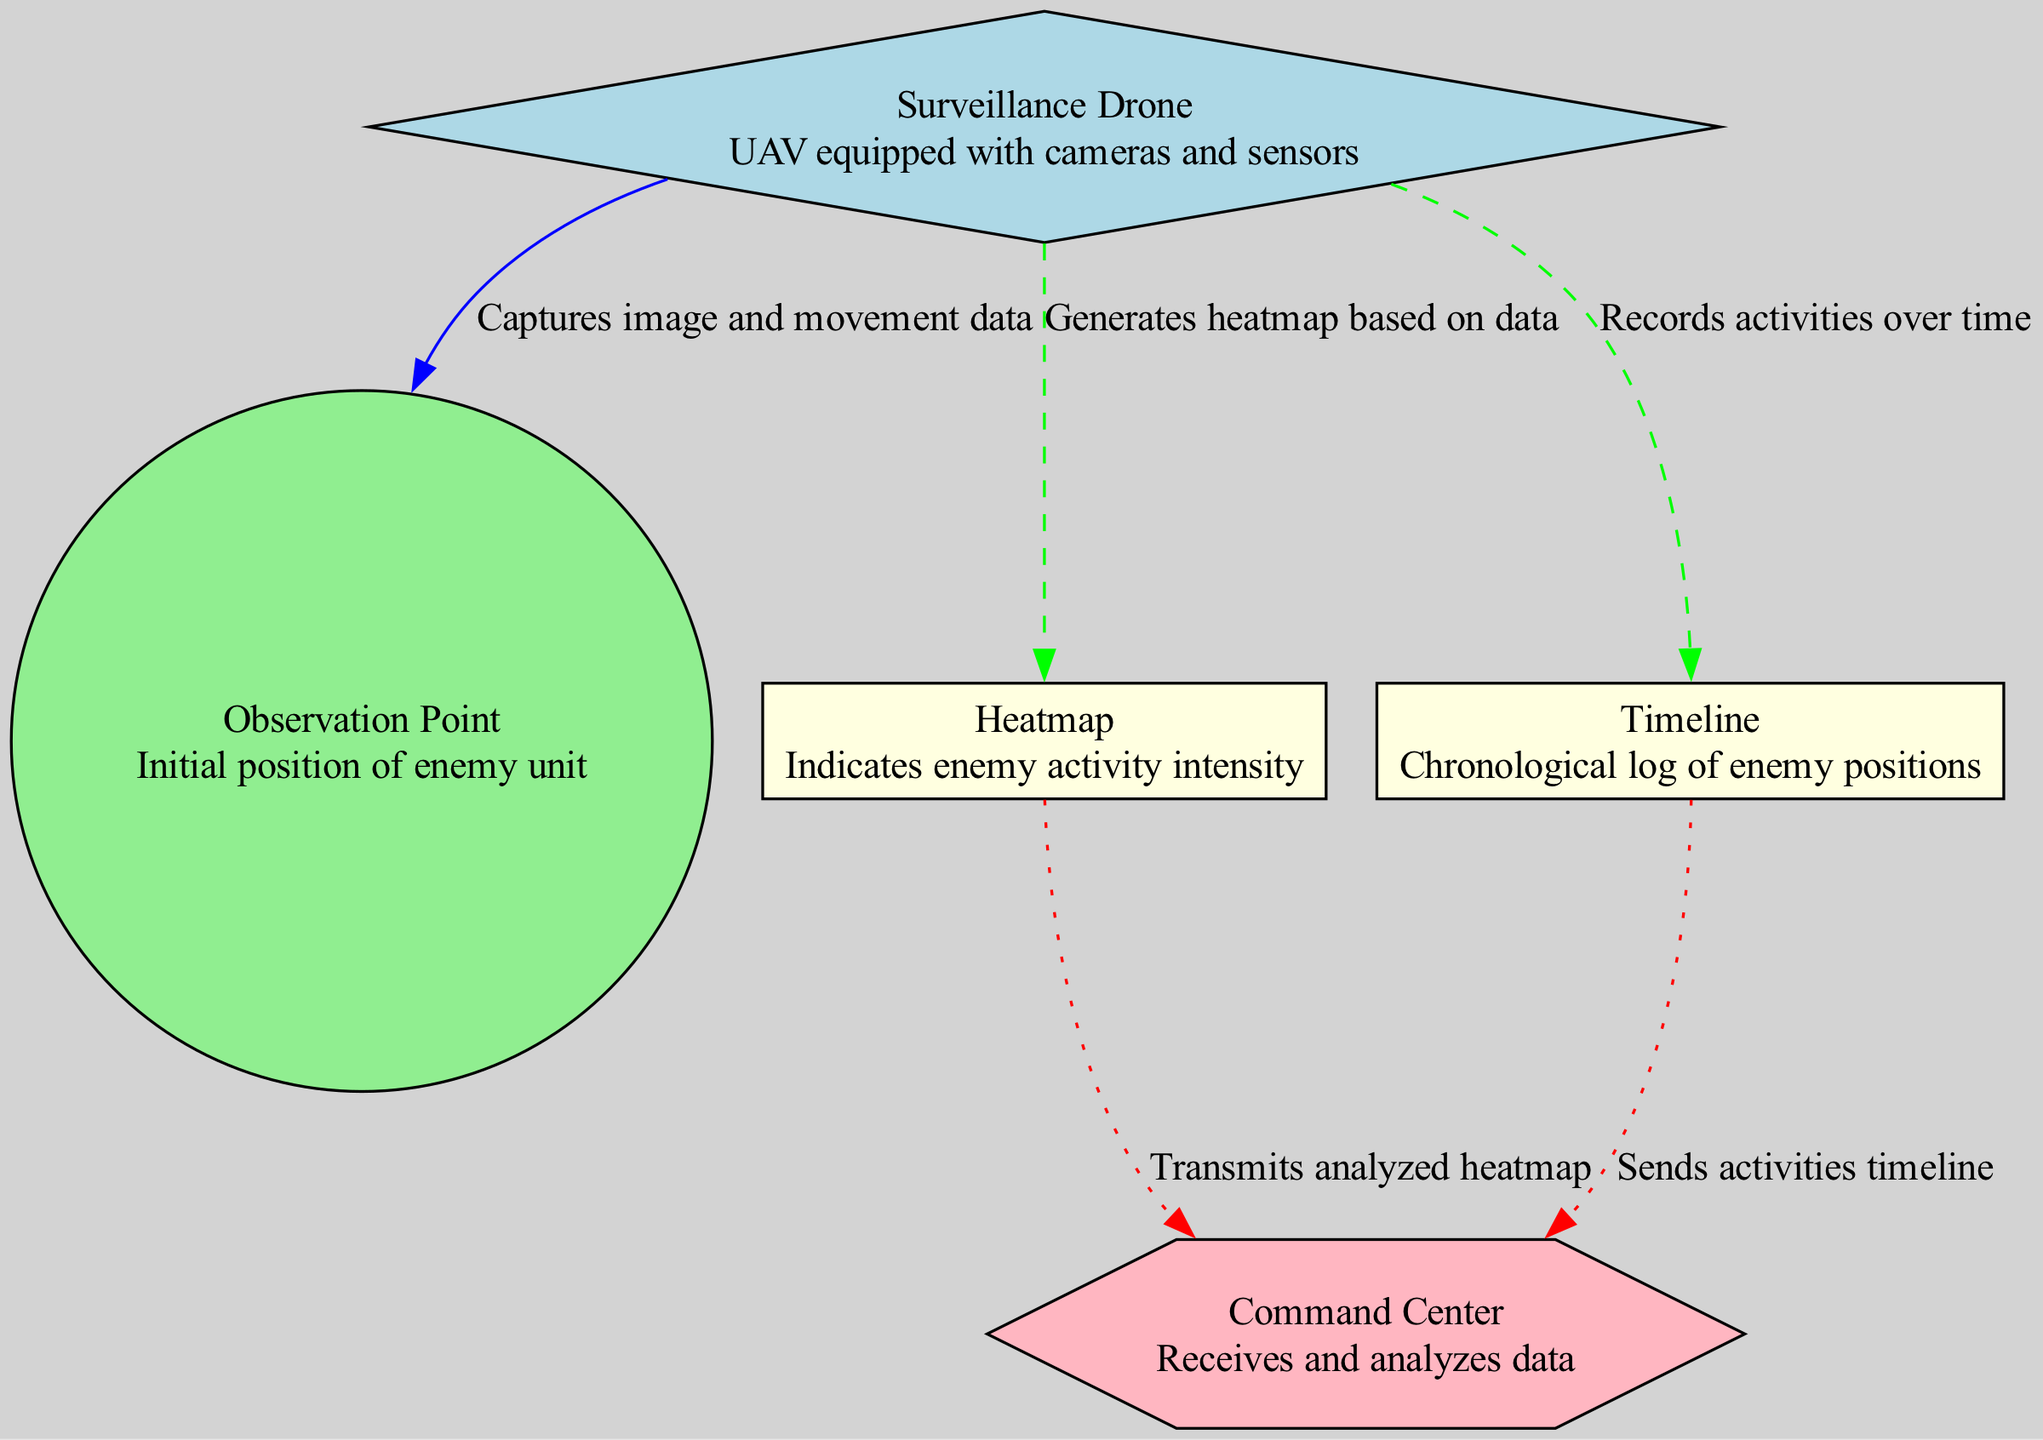What is the function of the Surveillance Drone in this diagram? The Surveillance Drone captures image and movement data from the Observation Point, which is indicated by the arrow connecting the drone to the location node.
Answer: Captures image and movement data How many nodes are present in the diagram? By counting the items listed under "nodes," there are five distinct nodes: Surveillance Drone, Observation Point, Heatmap, Timeline, and Command Center.
Answer: Five What type of visualization represents the intensity of enemy activity? The node labeled as Heatmap represents the intensity of enemy activity, as described in the node's information.
Answer: Heatmap What type of data flow occurs from the Heatmap to the Command Center? The connection from the Heatmap to the Command Center is described as data transmission, specifically indicated by the dotted line between these nodes.
Answer: Data transmission Which node is responsible for analyzing data? The Command Center node is designated as the one that receives and analyzes data, based on its description.
Answer: Command Center What is transmitted from the Timeline to the Command Center? The Timeline transmits the activities log to the Command Center, as indicated by the description of the edge connecting these nodes.
Answer: Sends activities timeline How does the diagram categorize the different types of nodes? Nodes are categorized based on their functionality: drones are diamonds, locations are circles, visualizations are rectangles, and analytical units are hexagons, illustrated by their unique shapes and colors.
Answer: By functionality Which process generates the heatmap? The heatmap is generated through data processing from the Surveillance Drone, as indicated by the dashed line leading from the drone to the heatmap node.
Answer: Data processing What relationship exists between the Surveillance Drone and the Observation Point? The relationship is a data flow where the drone captures image and movement data from the initial position of the enemy unit, represented by the directed edge between these nodes.
Answer: Data flow 